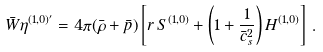Convert formula to latex. <formula><loc_0><loc_0><loc_500><loc_500>\bar { W } \eta ^ { ( 1 , 0 ) ^ { \prime } } = 4 \pi ( \bar { \rho } + \bar { p } ) \left [ r \, S ^ { ( 1 , 0 ) } + \left ( 1 + \frac { 1 } { \bar { c } ^ { 2 } _ { s } } \right ) H ^ { ( 1 , 0 ) } \right ] \, .</formula> 